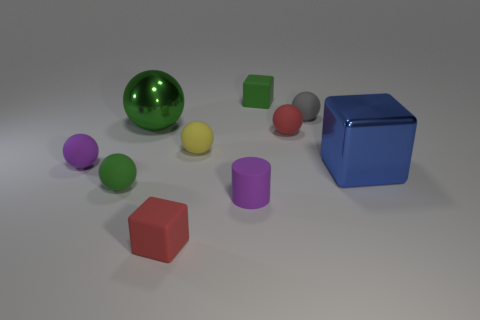What number of other objects are there of the same shape as the large blue object?
Make the answer very short. 2. What is the color of the cylinder that is the same size as the red rubber cube?
Ensure brevity in your answer.  Purple. Are there the same number of green shiny objects on the left side of the big green metallic thing and large blue metal things?
Provide a succinct answer. No. What is the shape of the tiny object that is both in front of the big green shiny ball and behind the small yellow matte object?
Ensure brevity in your answer.  Sphere. Is the size of the yellow thing the same as the green metallic sphere?
Your answer should be very brief. No. Is there a gray object made of the same material as the tiny green ball?
Your answer should be compact. Yes. There is another ball that is the same color as the large ball; what size is it?
Offer a very short reply. Small. What number of red matte things are behind the tiny purple rubber cylinder and in front of the small yellow ball?
Keep it short and to the point. 0. What is the material of the small block in front of the tiny gray object?
Offer a terse response. Rubber. How many large spheres have the same color as the tiny matte cylinder?
Ensure brevity in your answer.  0. 